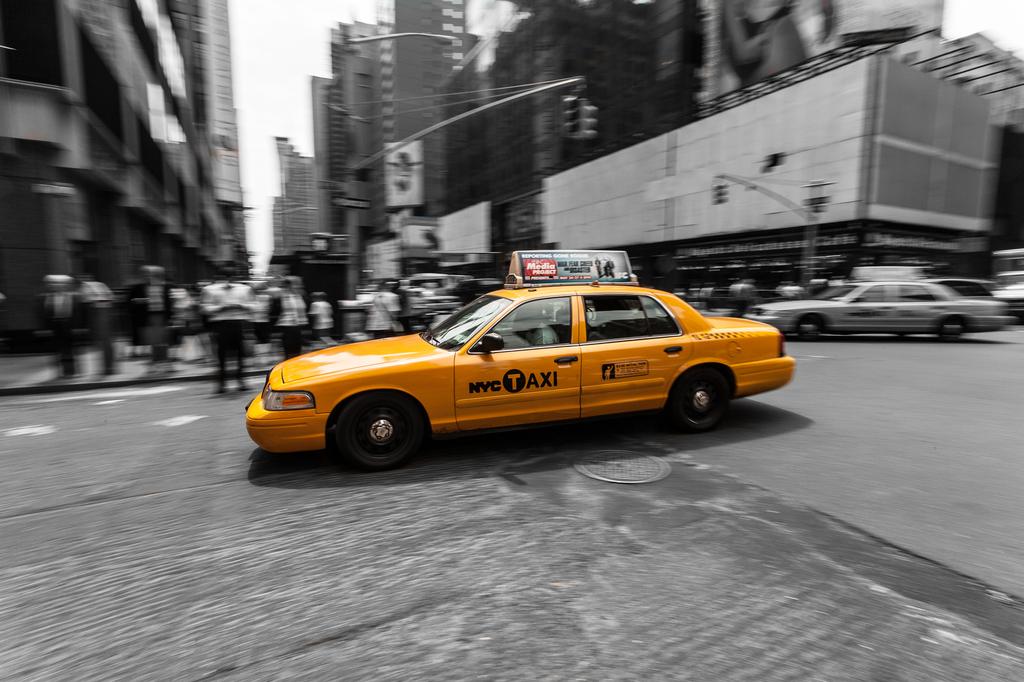What is written in white on the top of the taxi?
Keep it short and to the point. Media project. 